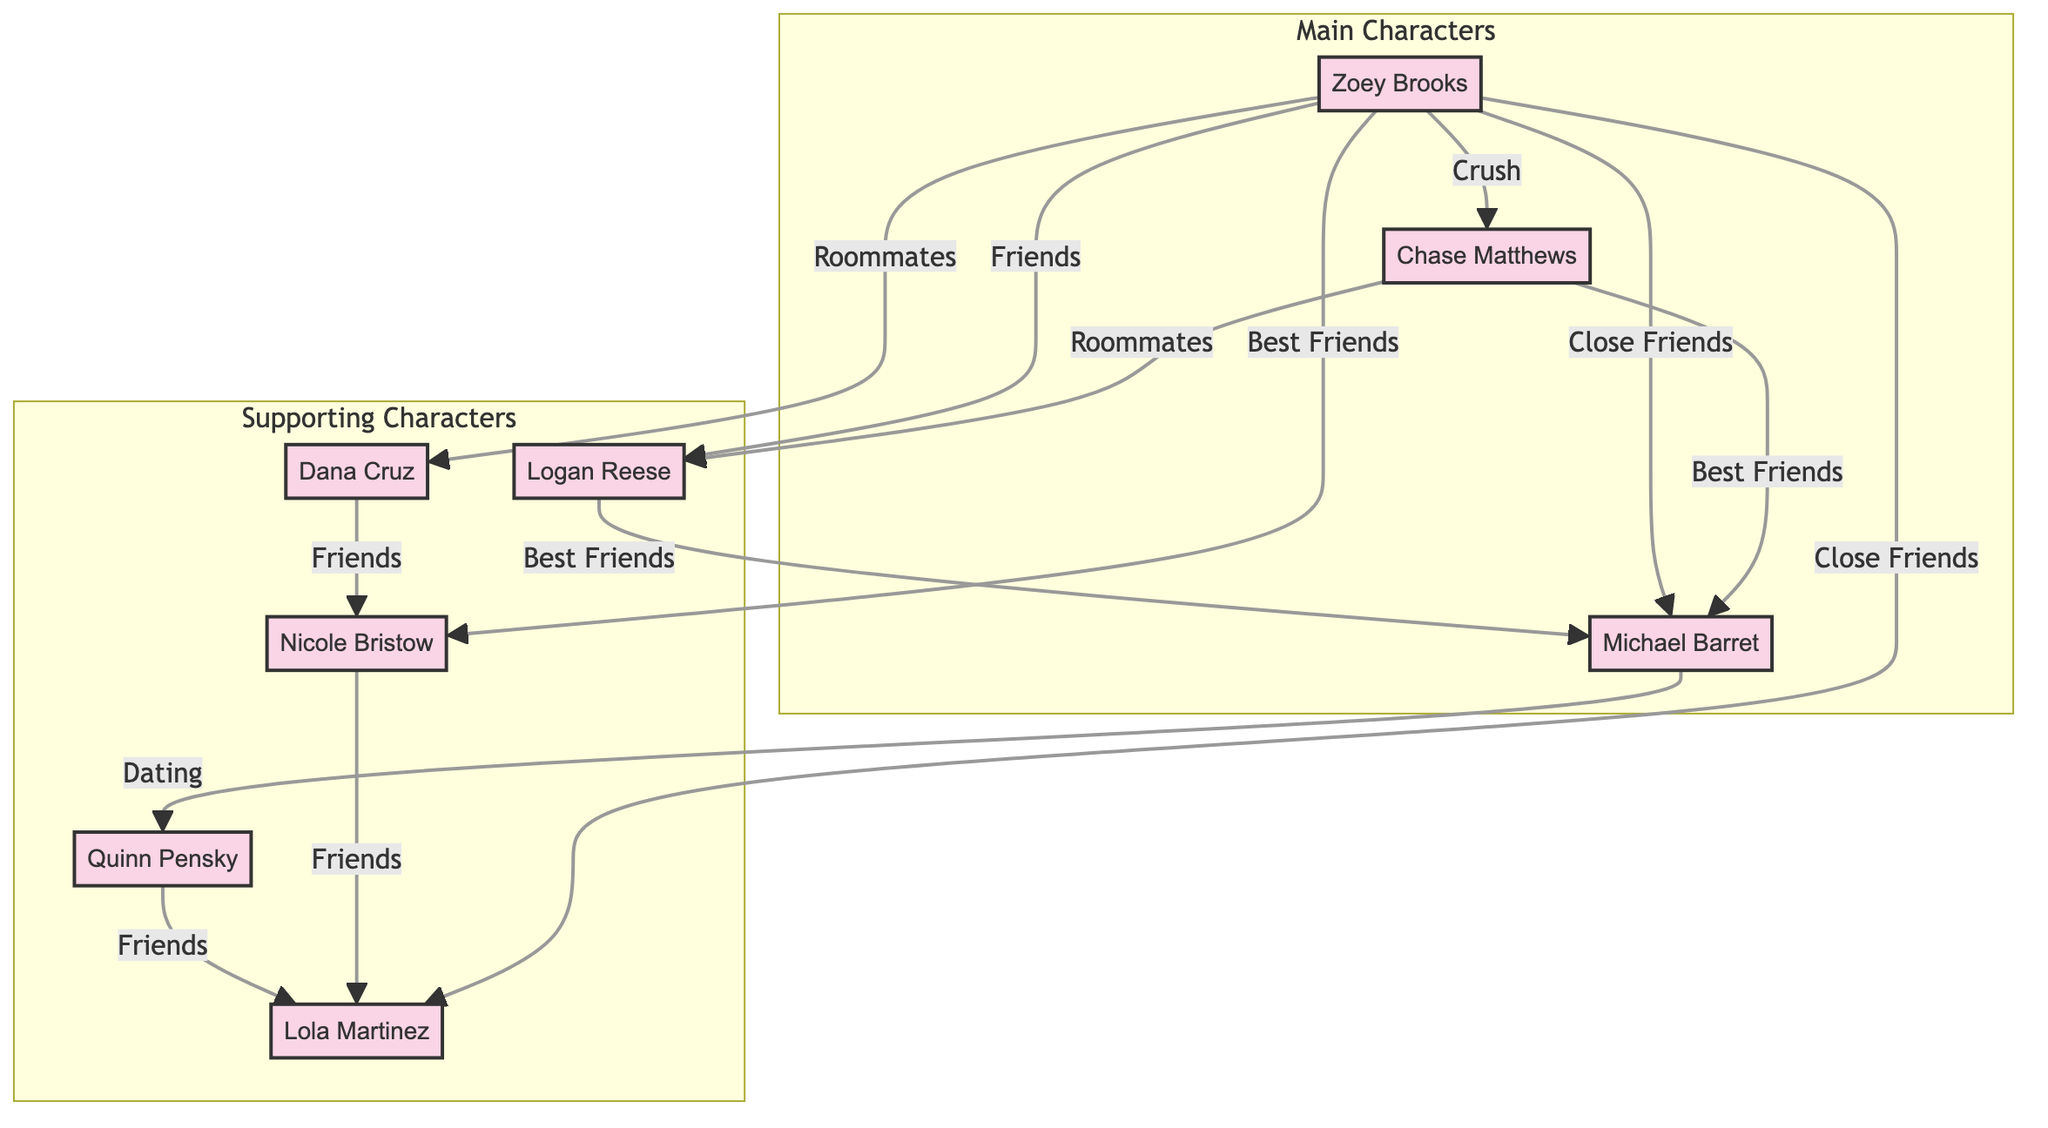What is the relationship type between Zoey and Chase? The diagram shows a direct connection labeled "Crush" between Zoey Brooks and Chase Matthews. This indicates that the nature of their relationship is that of a crush.
Answer: Crush How many main characters are represented in the diagram? The subgraph labeled "Main Characters" includes three nodes: Zoey Brooks, Chase Matthews, and Michael Barret. Thus, there are three main characters in total.
Answer: 3 Which character is Quinn Pensky dating? In the diagram, there is a direct connection labeled "Dating" that connects Michael Barret to Quinn Pensky. This indicates that Michael Barret is the one Quinn Pensky is dating.
Answer: Michael Barret How many friends does Nicole Bristow have in the diagram? Upon examination of the edges extending from Nicole Bristow, there are two relationships labeled "Friends" connected to her, one with Dana Cruz and one with Lola Martinez. Therefore, she has two friends in the diagram.
Answer: 2 Which character has the most connections in the diagram? By counting the connections, we can see that Zoey Brooks has six different relationships (with Chase, Dana, Nicole, Logan, Michael, and Lola). Thus, she has the most connections in the diagram.
Answer: Zoey Brooks What is the relationship between Michael Barret and Quinn Pensky? The direct connection between Michael Barret and Quinn Pensky is labeled "Dating," indicating that they are in a romantic relationship.
Answer: Dating Which character is both a best friend and roommate of another character? The diagram shows that Chase Matthews is both the roomie of Logan Reese and a best friend to Michael Barret, indicating he has these two distinct types of relationships with them.
Answer: Chase Matthews 